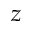<formula> <loc_0><loc_0><loc_500><loc_500>z</formula> 